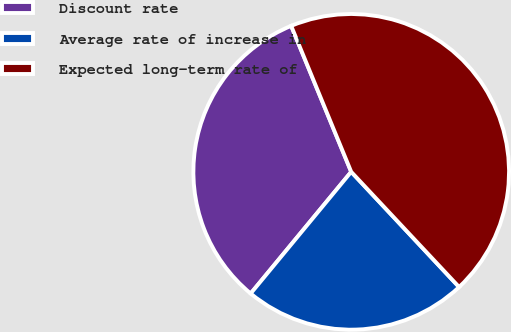Convert chart to OTSL. <chart><loc_0><loc_0><loc_500><loc_500><pie_chart><fcel>Discount rate<fcel>Average rate of increase in<fcel>Expected long-term rate of<nl><fcel>32.8%<fcel>22.97%<fcel>44.23%<nl></chart> 